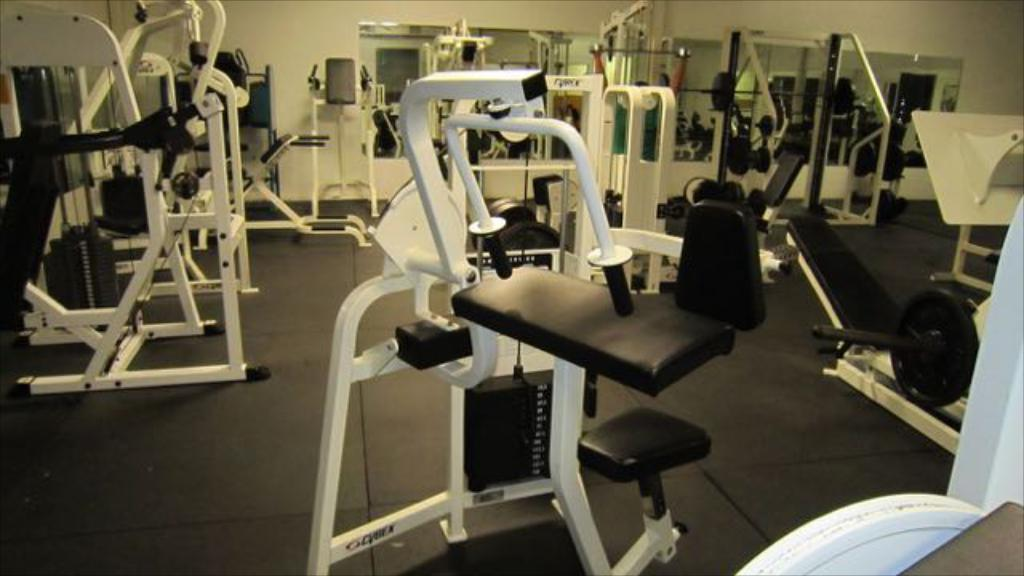What type of space is shown in the image? The image depicts a room. What can be found in the room? The room contains gym equipment. What feature is present on the walls of the room? Mirrors are present on the walls of the room. Where is the toothbrush located in the image? There is no toothbrush present in the image. Can you see a yak or a zebra in the image? Neither a yak nor a zebra is present in the image. 